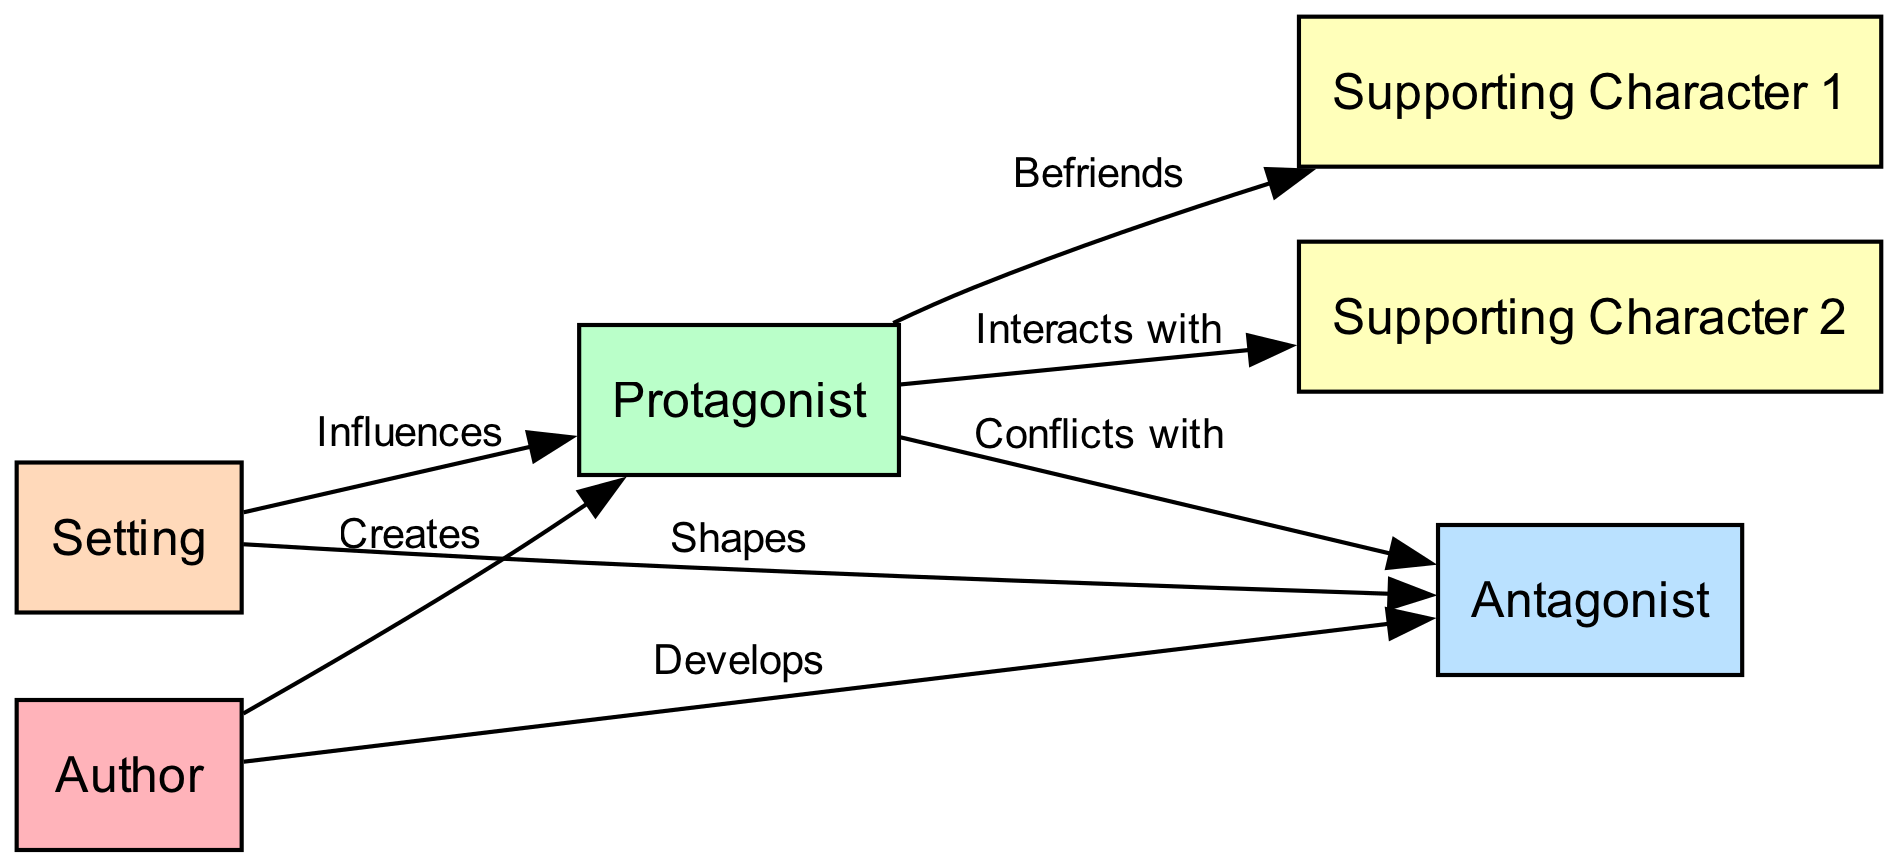What is the total number of nodes in the diagram? The diagram includes six nodes: Author, Protagonist, Antagonist, Supporting Character 1, Supporting Character 2, and Setting. Count each of these to find the total.
Answer: 6 Which character does the Author develop? The edge labeled "Develops" connecting Author to Antagonist indicates that the Author is responsible for developing this character.
Answer: Antagonist Who does the Protagonist befriend? The edge labeled "Befriends" between Protagonist and Supporting Character 1 indicates the relationship of friendship formed by the Protagonist.
Answer: Supporting Character 1 How many interactions does the Protagonist have according to the diagram? The Protagonist interacts with two characters: Supporting Character 1 (as a friend) and Supporting Character 2 (as an interaction). These connections can be counted from the edges.
Answer: 2 What influence does the Setting have on the Protagonist? The edge labeled "Influences" showing the connection from Setting to Protagonist indicates that the Setting has a direct influence on this character.
Answer: Influences What is the nature of the conflict between the Protagonist and the Antagonist? The relationship labeled "Conflicts with" reveals that the Protagonist is in conflict with the Antagonist, emphasizing the opposing roles they play in the narrative.
Answer: Conflicts with Which character does the Setting shape? The edge connecting Setting to Antagonist is labeled "Shapes," indicating that the Setting uniquely impacts and shapes the Antagonist's character.
Answer: Antagonist Identify the type of relationship between Protagonist and Supporting Character 2. The relationship between Protagonist and Supporting Character 2 is described by the edge labeled "Interacts with," indicating that the Protagonist engages with Supporting Character 2.
Answer: Interacts with How many edges connect the Protagonist to other characters? The Protagonist is connected to the Antagonist (conflict), Supporting Character 1 (friendship), and Supporting Character 2 (interaction), totaling three edges. Count these edges connected to the Protagonist to find the total.
Answer: 3 